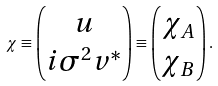Convert formula to latex. <formula><loc_0><loc_0><loc_500><loc_500>\chi \equiv \left ( \begin{matrix} u \\ i \sigma ^ { 2 } v ^ { * } \end{matrix} \right ) \equiv \left ( \begin{matrix} \chi _ { A } \\ \chi _ { B } \end{matrix} \right ) .</formula> 